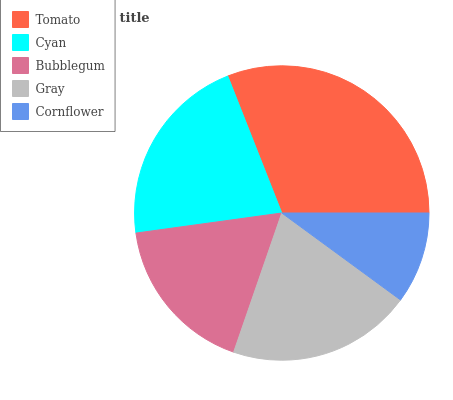Is Cornflower the minimum?
Answer yes or no. Yes. Is Tomato the maximum?
Answer yes or no. Yes. Is Cyan the minimum?
Answer yes or no. No. Is Cyan the maximum?
Answer yes or no. No. Is Tomato greater than Cyan?
Answer yes or no. Yes. Is Cyan less than Tomato?
Answer yes or no. Yes. Is Cyan greater than Tomato?
Answer yes or no. No. Is Tomato less than Cyan?
Answer yes or no. No. Is Gray the high median?
Answer yes or no. Yes. Is Gray the low median?
Answer yes or no. Yes. Is Bubblegum the high median?
Answer yes or no. No. Is Cyan the low median?
Answer yes or no. No. 